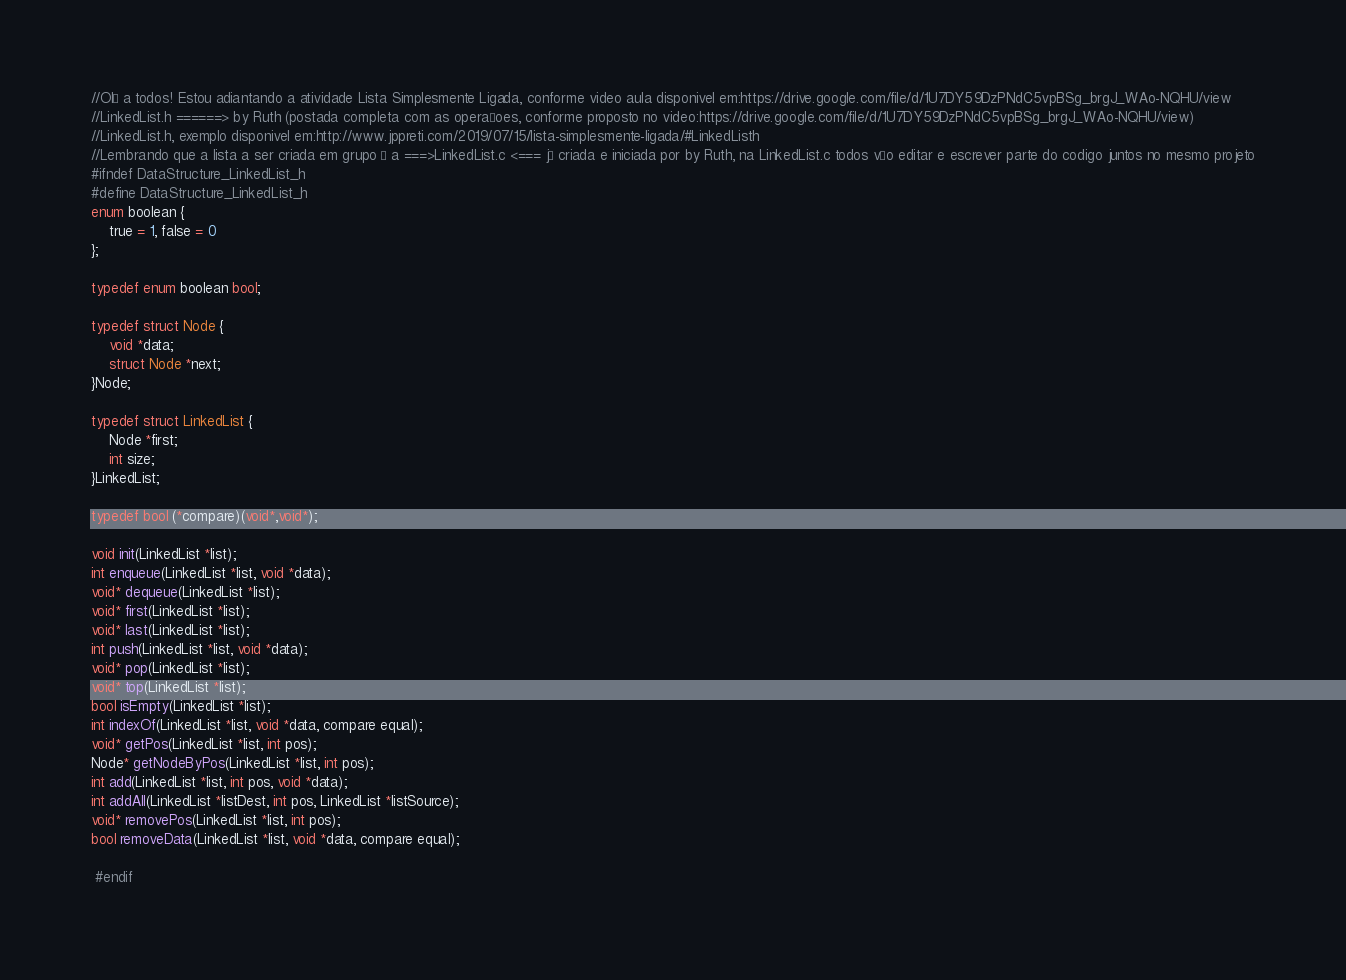<code> <loc_0><loc_0><loc_500><loc_500><_C_>//Olá a todos! Estou adiantando a atividade Lista Simplesmente Ligada, conforme video aula disponivel em:https://drive.google.com/file/d/1U7DY59DzPNdC5vpBSg_brgJ_WAo-NQHU/view
//LinkedList.h ======> by Ruth (postada completa com as operaçoes, conforme proposto no video:https://drive.google.com/file/d/1U7DY59DzPNdC5vpBSg_brgJ_WAo-NQHU/view)
//LinkedList.h, exemplo disponivel em:http://www.jppreti.com/2019/07/15/lista-simplesmente-ligada/#LinkedListh
//Lembrando que a lista a ser criada em grupo é a ===>LinkedList.c <=== já criada e iniciada por by Ruth, na LinkedList.c todos vão editar e escrever parte do codigo juntos no mesmo projeto
#ifndef DataStructure_LinkedList_h
#define DataStructure_LinkedList_h
enum boolean {
    true = 1, false = 0
};

typedef enum boolean bool;

typedef struct Node {
    void *data;
    struct Node *next;
}Node;

typedef struct LinkedList {
    Node *first;
    int size;
}LinkedList;

typedef bool (*compare)(void*,void*);

void init(LinkedList *list);
int enqueue(LinkedList *list, void *data);
void* dequeue(LinkedList *list);
void* first(LinkedList *list);
void* last(LinkedList *list);
int push(LinkedList *list, void *data);
void* pop(LinkedList *list);
void* top(LinkedList *list);
bool isEmpty(LinkedList *list);
int indexOf(LinkedList *list, void *data, compare equal);
void* getPos(LinkedList *list, int pos);
Node* getNodeByPos(LinkedList *list, int pos);
int add(LinkedList *list, int pos, void *data);
int addAll(LinkedList *listDest, int pos, LinkedList *listSource);
void* removePos(LinkedList *list, int pos);
bool removeData(LinkedList *list, void *data, compare equal);

 #endif</code> 